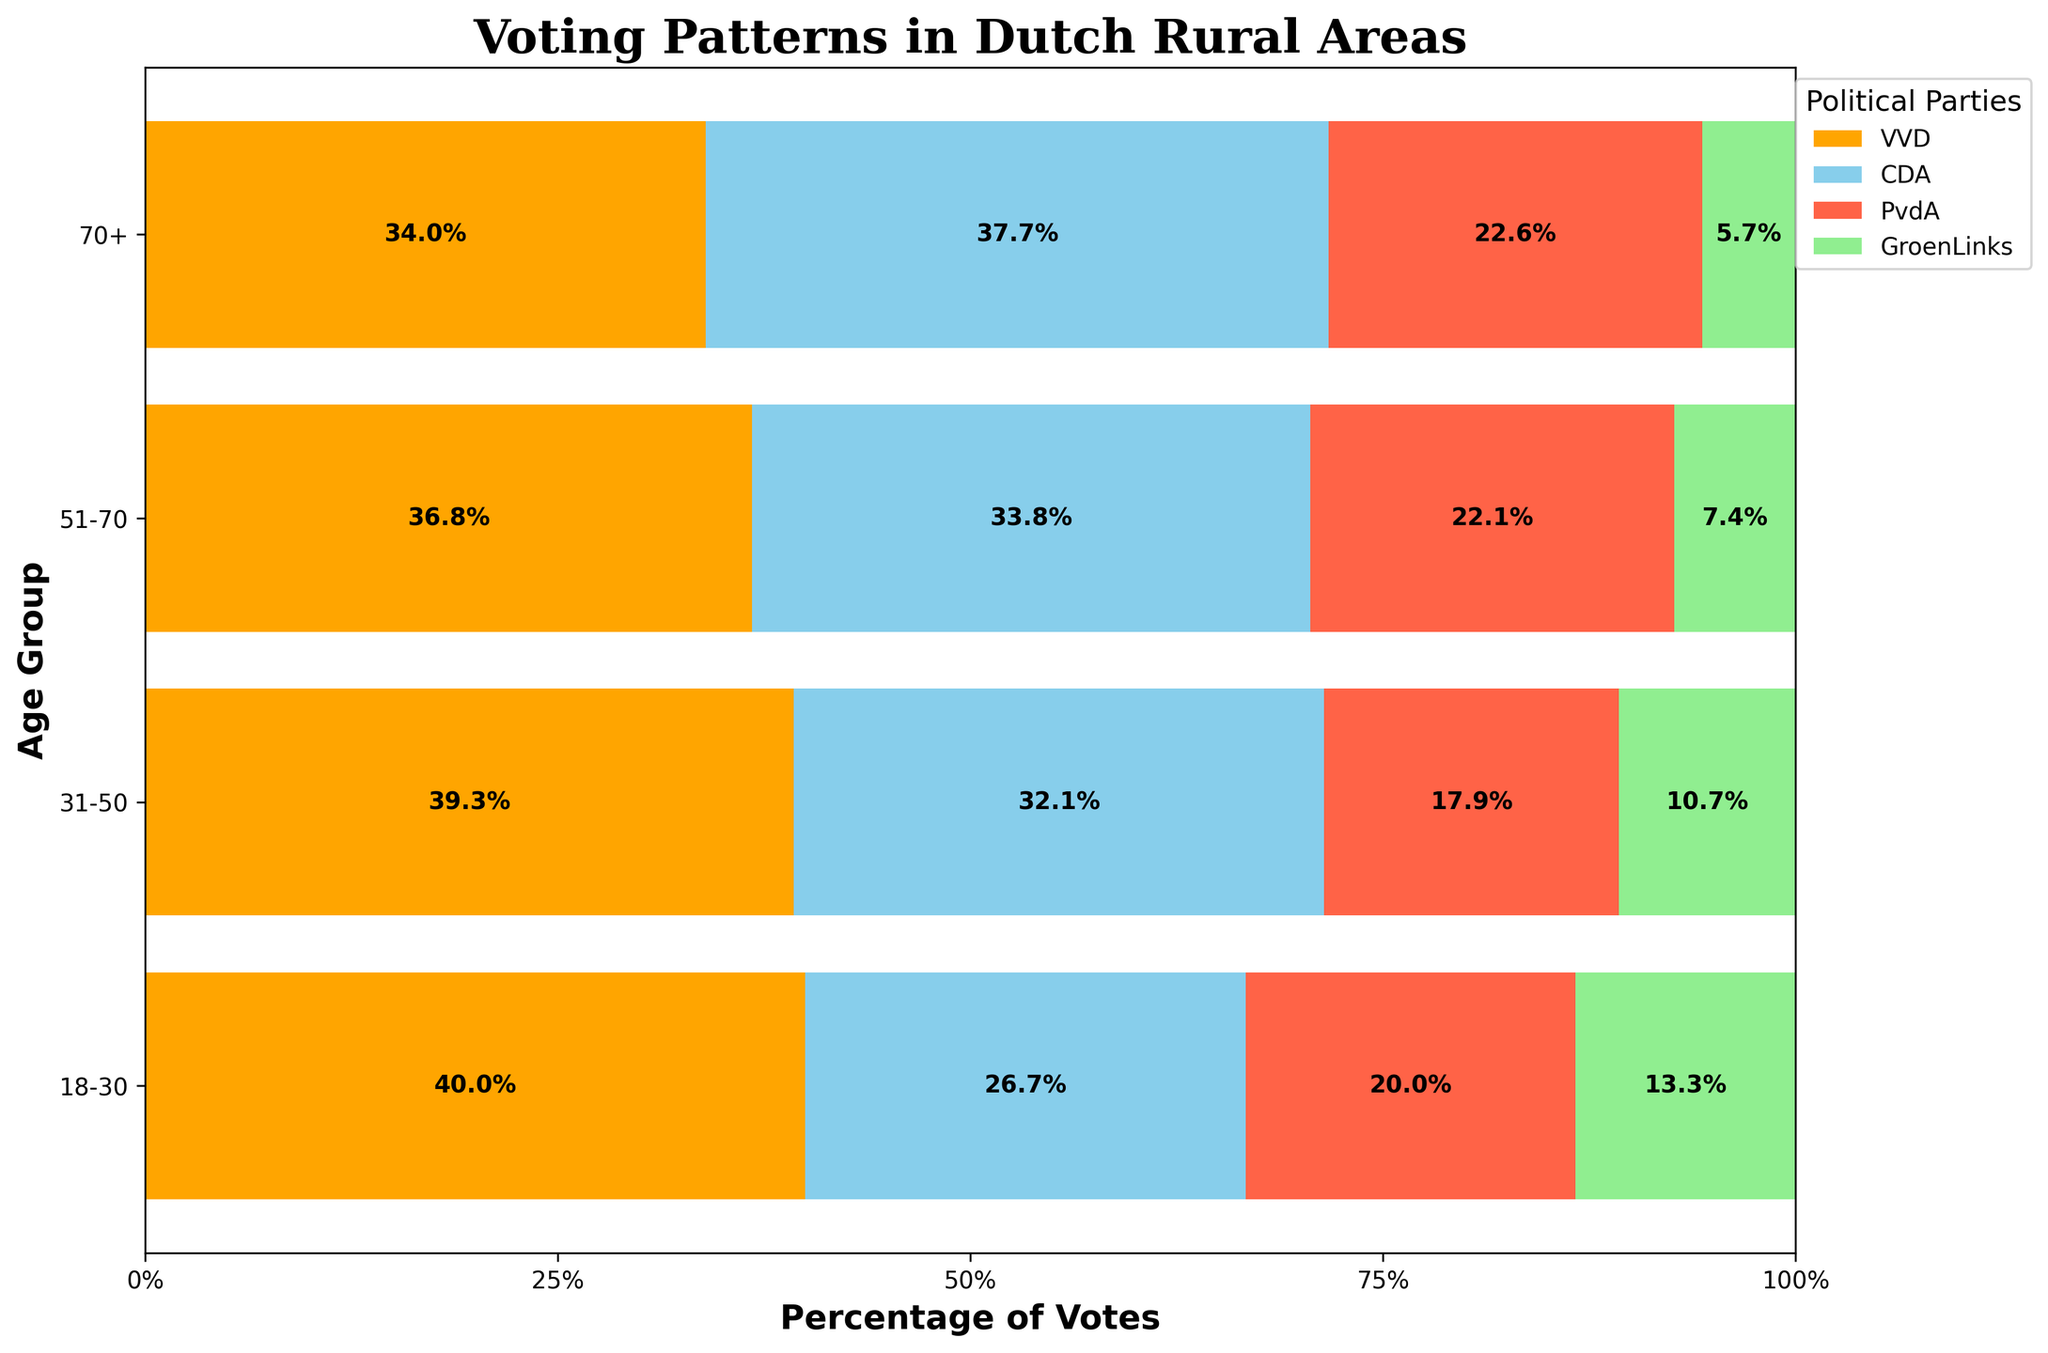What is the title of the plot? The title of the plot is written at the top and reads "Voting Patterns in Dutch Rural Areas".
Answer: Voting Patterns in Dutch Rural Areas Which political party shows the highest percentage of votes in the age group 51-70? To determine which party has the highest percentage of votes, observe the width of the colored bar segments for the 51-70 age group. The yellow bar (VVD) is the widest in this age group, indicating the highest percentage.
Answer: VVD How do the percentages of votes for CDA change across the different age groups? Look at the blue segments (CDA) for each age group and compare their proportions. CDA starts at 26.7% (800/3000) in the 18-30 group, increases to 30% (1800/6000) in the 31-50 group, further increases to 38.3% (2300/6000) in the 51-70 group, and slightly decreases to 33.3% (2000/6000) in the 70+ group.
Answer: Increase, stabilize at peak, then decrease slightly Which age group gives the least percentage of votes to GroenLinks? Identify the smallest green segment that represents the GroenLinks votes percentage across age groups. For the 70+ age group, GroenLinks has the smallest share compared to other age groups, indicating it receives the least percentage of votes from this age group.
Answer: 70+ Compare the percentages of votes for PvdA between the youngest (18-30) and oldest (70+) age groups. Which one has a higher percentage? Examine the PvdA segments (red) for the 18-30 and 70+ age groups. For 18-30, it is 20% (600/3000); for 70+, it is 20% (1200/6000). Both age groups have the same percentage of PvdA votes.
Answer: Equal What is the percentage difference of VVD votes between the age groups 31-50 and 70+? Calculate the percentage of VVD votes in each group: for 31-50 it is 36.7% (2200/6000), and for 70+ it is 30% (1800/6000). The difference is 36.7% - 30% = 6.7%.
Answer: 6.7% Which political party has the smallest percentage range of votes across different age groups? Determine the range by identifying the smallest and largest percentages for each party. GroenLinks has the smallest range: 13.3% (18-30) to 5% (70+). The range is 13.3% - 5% = 8.3%.
Answer: GroenLinks How does the overall trend for VVD votes across age groups appear? Observe the yellow segments (VVD) across all age groups. VVD starts at 40% (1200/3000) in 18-30, peaks at 36.7% (2200/6000) in 31-50, remains high at 41.7% (2500/6000) in 51-70, and then decreases to 30% (1800/6000) in 70+. This indicates a general trend of decrease.
Answer: Decrease with age What can be inferred about the voting patterns of the age group 51-70 based on the plot? Analyze all segments within the 51-70 age group. VVD holds the highest percentage (41.7%), followed by CDA (38.3%), PvdA (25%), and GroenLinks (8.3%) is the lowest. This suggests that middle-aged voters lean more towards VVD and CDA, with VVD being the most favored.
Answer: Middle-aged favor VVD and CDA 